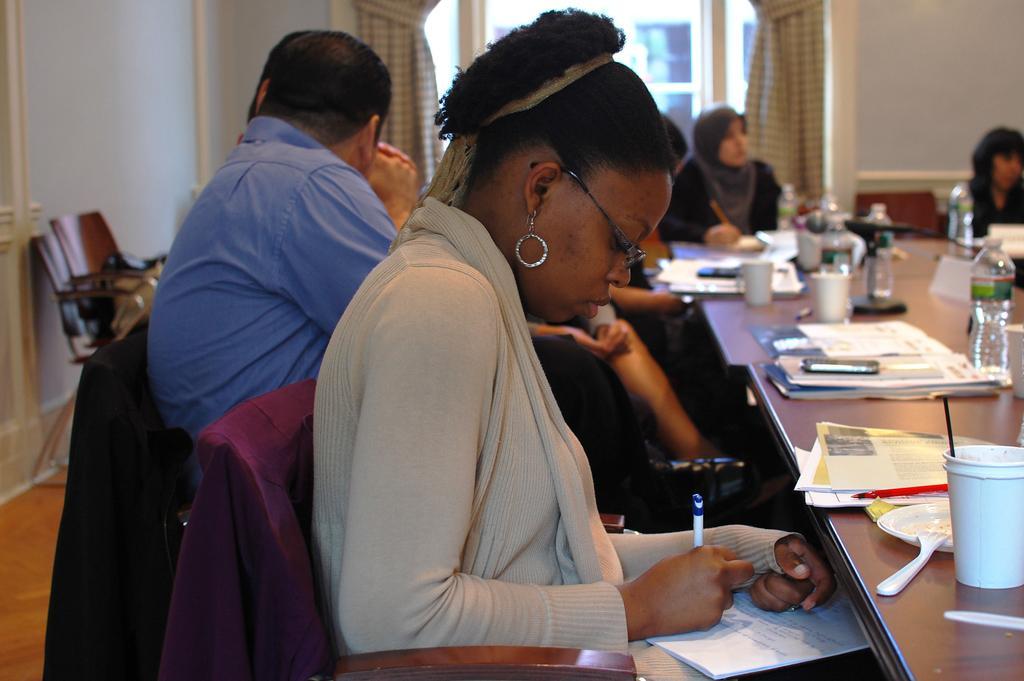Can you describe this image briefly? In this image I can see group of people sitting, the person in front wearing gray color dress and holding a pen and few papers, in front I can see few bottles, glasses, papers, spoons on the table. Background I can see a wall in white color, few curtains and a window. 